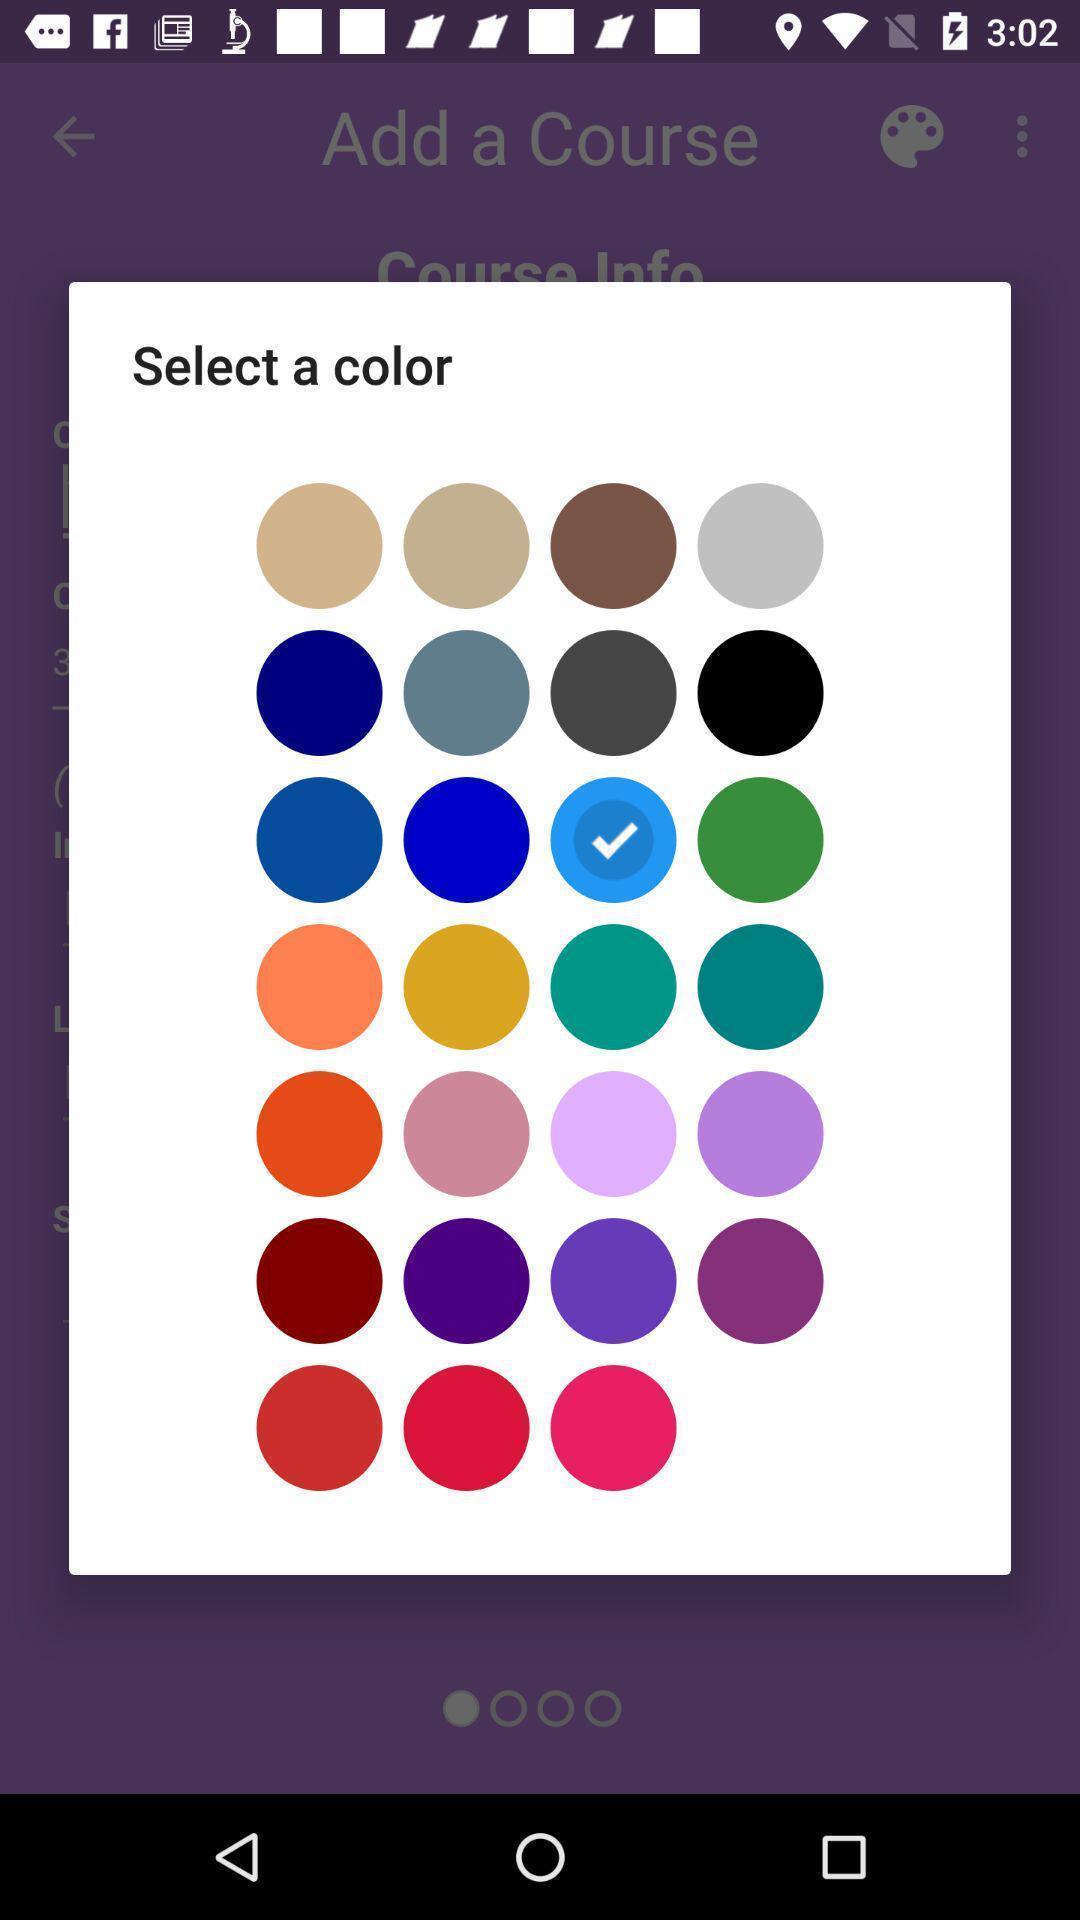Provide a description of this screenshot. Pop-up showing option to select color. 